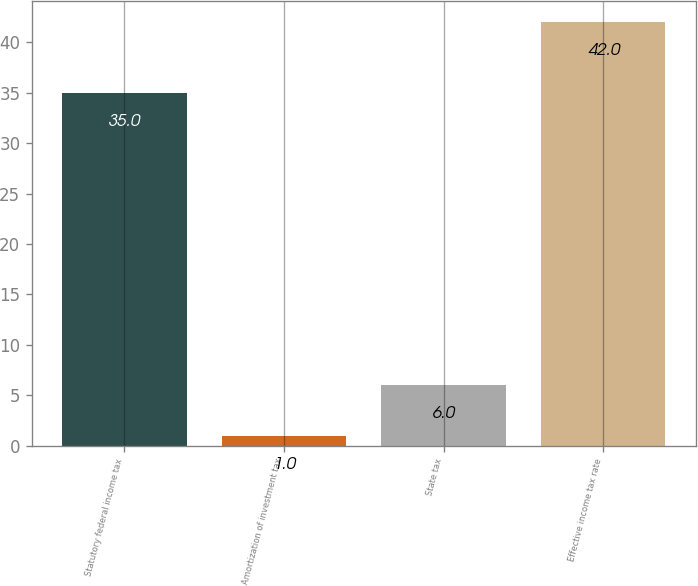Convert chart. <chart><loc_0><loc_0><loc_500><loc_500><bar_chart><fcel>Statutory federal income tax<fcel>Amortization of investment tax<fcel>State tax<fcel>Effective income tax rate<nl><fcel>35<fcel>1<fcel>6<fcel>42<nl></chart> 